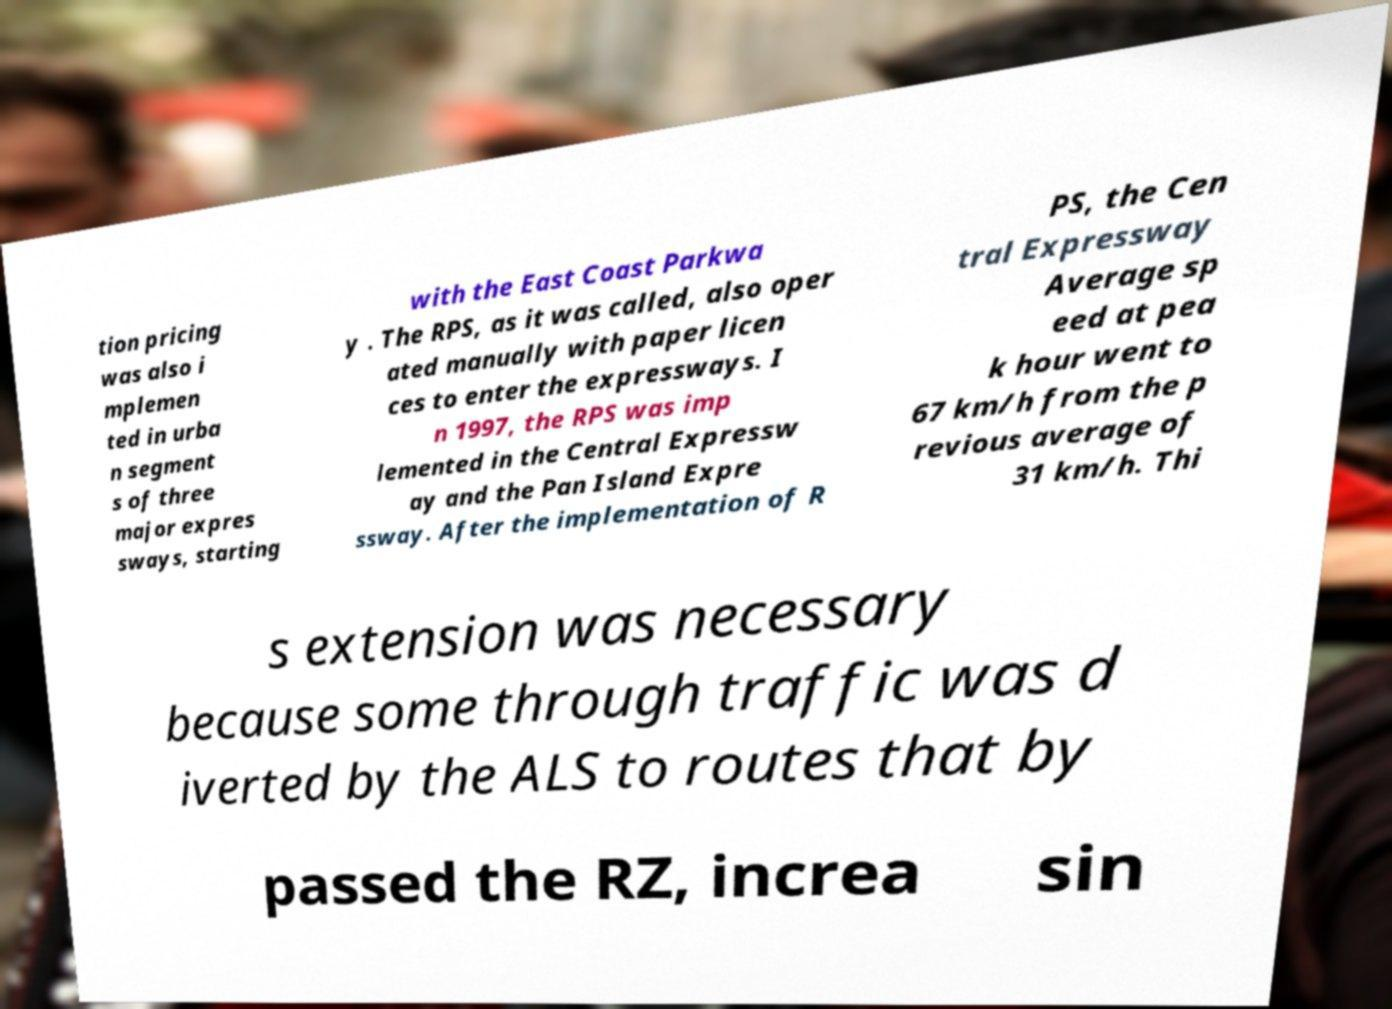Please identify and transcribe the text found in this image. tion pricing was also i mplemen ted in urba n segment s of three major expres sways, starting with the East Coast Parkwa y . The RPS, as it was called, also oper ated manually with paper licen ces to enter the expressways. I n 1997, the RPS was imp lemented in the Central Expressw ay and the Pan Island Expre ssway. After the implementation of R PS, the Cen tral Expressway Average sp eed at pea k hour went to 67 km/h from the p revious average of 31 km/h. Thi s extension was necessary because some through traffic was d iverted by the ALS to routes that by passed the RZ, increa sin 